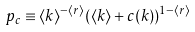Convert formula to latex. <formula><loc_0><loc_0><loc_500><loc_500>p _ { c } \equiv \langle k \rangle ^ { - \langle r \rangle } ( \langle k \rangle + c ( k ) ) ^ { 1 - \langle r \rangle }</formula> 